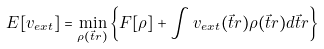<formula> <loc_0><loc_0><loc_500><loc_500>E [ v _ { e x t } ] = \underset { \rho ( \vec { t } { r } ) } { \min } \left \{ F [ \rho ] + \int v _ { e x t } ( \vec { t } { r } ) \rho ( \vec { t } { r } ) d \vec { t } { r } \right \}</formula> 